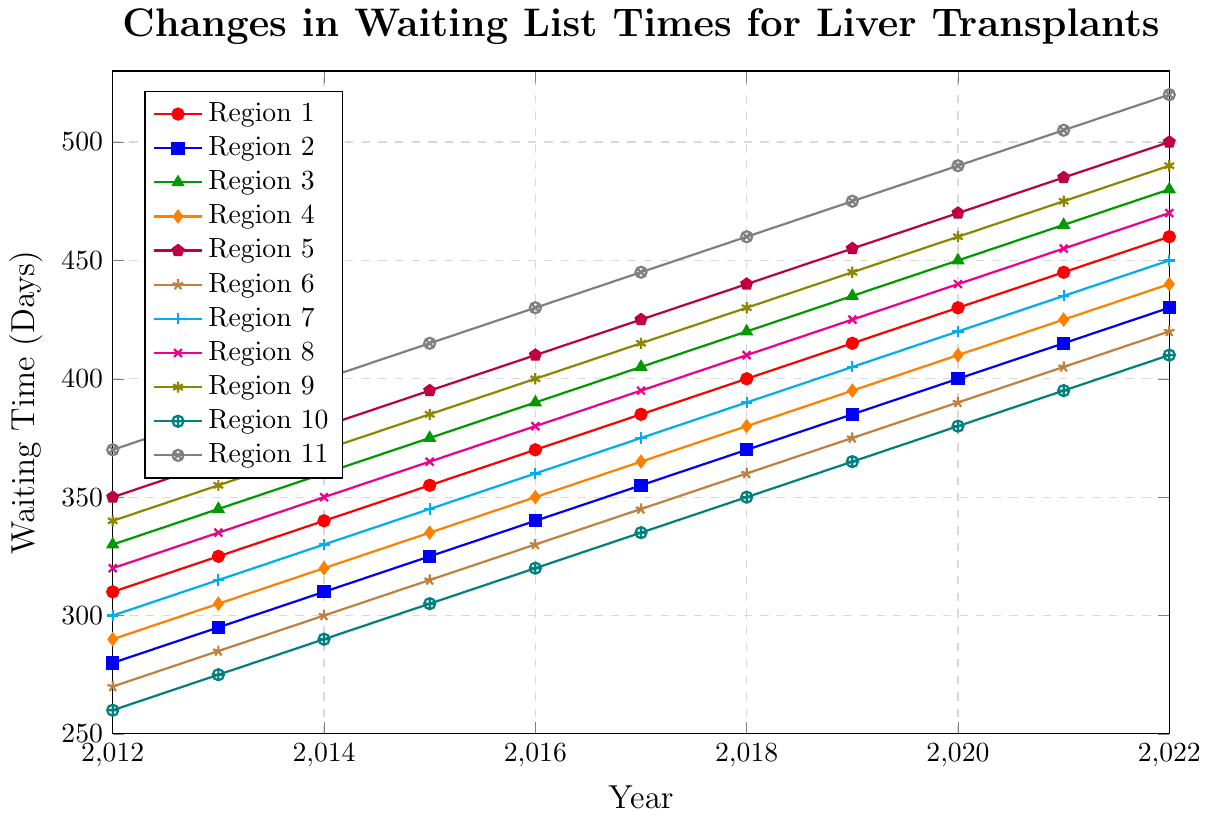What was the waiting time for liver transplants in Region 1 in 2012 compared to 2022? To find the answer, locate the line corresponding to Region 1 on the chart. Note the waiting time values for the years 2012 and 2022. In 2012, the waiting time is 310 days and in 2022, it is 460 days.
Answer: 310 days in 2012, 460 days in 2022 Which region had the longest waiting time in 2022? To determine the region with the longest waiting time in 2022, examine the endpoints of all lines in the graph for the year 2022 and find the highest value. Region 11 has the highest endpoint at 520 days.
Answer: Region 11 Which region shows the smallest increase in waiting time from 2012 to 2022? To identify the region with the smallest increase, compute the difference between the waiting times for 2022 and 2012 for each region and find the minimum. Region 10 has an increase of 410 - 260 = 150 days. This is the smallest among all regions.
Answer: Region 10 What's the average waiting time for liver transplants across all regions in 2022? To calculate the average waiting time for 2022, sum the waiting times for all regions in 2022 and divide by the number of regions. The sum is 460 + 430 + 480 + 440 + 500 + 420 + 450 + 470 + 490 + 410 + 520 = 5370. Dividing by 11 regions gives the average 5370 / 11 ≈ 488.18 days.
Answer: 488.18 days Between which years did Region 5 see its largest year-over-year increase in waiting time? To find this, examine the changes in waiting time for Region 5 from year to year. The largest increase is between 2021 (485 days) and 2022 (500 days), where the increase is 500 - 485 = 15 days.
Answer: 2021 to 2022 Which region had the smallest waiting time in 2020? To find the region with the smallest waiting time in 2020, locate the waiting times for all regions in 2020 and identify the lowest value. Region 10 had the smallest waiting time of 380 days in 2020.
Answer: Region 10 What is the average increase in waiting time per year for Region 3 from 2012 to 2022? To calculate the average annual increase, subtract the waiting time in 2012 from the waiting time in 2022, and then divide by the number of years. For Region 3, the increase is 480 - 330 = 150 days. Dividing by 10 years gives an average increase of 150 / 10 = 15 days per year.
Answer: 15 days per year Which year had the greatest combined waiting time across all regions? Calculate the sum of waiting times for each year and determine the year with the highest total. Summing for all regions, the totals are as follows. The year 2022 has the greatest combined total of 5370 days.
Answer: 2022 How does the waiting time trend for Region 6 from 2012 to 2022 compare to Region 11? Compare the slope of the lines for Region 6 and Region 11. For Region 6, the trend is a steady increase from 270 to 420 days. For Region 11, the trend is a steady increase from 370 to 520 days, which is a higher slope. This indicates that Region 11 had a steeper increase in waiting time compared to Region 6.
Answer: Region 11 has a steeper increase 